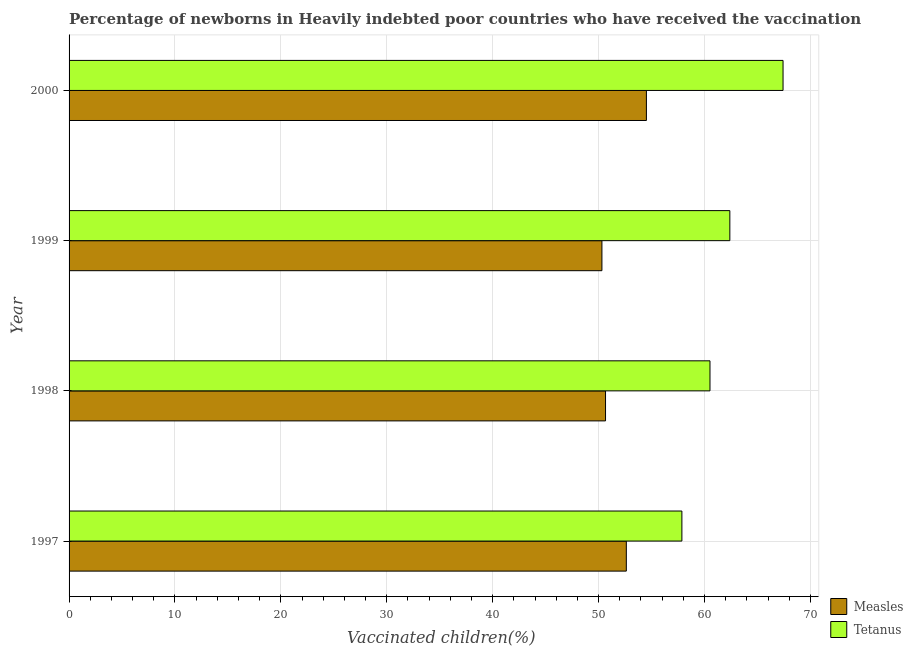How many different coloured bars are there?
Provide a short and direct response. 2. How many groups of bars are there?
Make the answer very short. 4. Are the number of bars per tick equal to the number of legend labels?
Your answer should be compact. Yes. How many bars are there on the 4th tick from the bottom?
Keep it short and to the point. 2. What is the label of the 3rd group of bars from the top?
Your answer should be compact. 1998. In how many cases, is the number of bars for a given year not equal to the number of legend labels?
Your answer should be compact. 0. What is the percentage of newborns who received vaccination for measles in 1997?
Provide a short and direct response. 52.62. Across all years, what is the maximum percentage of newborns who received vaccination for measles?
Keep it short and to the point. 54.51. Across all years, what is the minimum percentage of newborns who received vaccination for tetanus?
Your answer should be compact. 57.86. In which year was the percentage of newborns who received vaccination for tetanus minimum?
Your response must be concise. 1997. What is the total percentage of newborns who received vaccination for tetanus in the graph?
Keep it short and to the point. 248.18. What is the difference between the percentage of newborns who received vaccination for tetanus in 1998 and that in 2000?
Provide a succinct answer. -6.9. What is the difference between the percentage of newborns who received vaccination for tetanus in 1997 and the percentage of newborns who received vaccination for measles in 1999?
Keep it short and to the point. 7.55. What is the average percentage of newborns who received vaccination for measles per year?
Keep it short and to the point. 52.02. In the year 1998, what is the difference between the percentage of newborns who received vaccination for tetanus and percentage of newborns who received vaccination for measles?
Your answer should be very brief. 9.86. What is the ratio of the percentage of newborns who received vaccination for tetanus in 1999 to that in 2000?
Make the answer very short. 0.93. Is the percentage of newborns who received vaccination for measles in 1999 less than that in 2000?
Provide a succinct answer. Yes. What is the difference between the highest and the second highest percentage of newborns who received vaccination for tetanus?
Offer a terse response. 5.02. What is the difference between the highest and the lowest percentage of newborns who received vaccination for tetanus?
Ensure brevity in your answer.  9.55. In how many years, is the percentage of newborns who received vaccination for measles greater than the average percentage of newborns who received vaccination for measles taken over all years?
Make the answer very short. 2. Is the sum of the percentage of newborns who received vaccination for measles in 1998 and 2000 greater than the maximum percentage of newborns who received vaccination for tetanus across all years?
Your response must be concise. Yes. What does the 1st bar from the top in 1999 represents?
Your answer should be compact. Tetanus. What does the 2nd bar from the bottom in 2000 represents?
Offer a very short reply. Tetanus. How many years are there in the graph?
Ensure brevity in your answer.  4. Does the graph contain grids?
Provide a succinct answer. Yes. How many legend labels are there?
Keep it short and to the point. 2. What is the title of the graph?
Your answer should be very brief. Percentage of newborns in Heavily indebted poor countries who have received the vaccination. Does "Arms imports" appear as one of the legend labels in the graph?
Provide a succinct answer. No. What is the label or title of the X-axis?
Provide a short and direct response. Vaccinated children(%)
. What is the label or title of the Y-axis?
Offer a terse response. Year. What is the Vaccinated children(%)
 in Measles in 1997?
Make the answer very short. 52.62. What is the Vaccinated children(%)
 in Tetanus in 1997?
Keep it short and to the point. 57.86. What is the Vaccinated children(%)
 in Measles in 1998?
Offer a terse response. 50.65. What is the Vaccinated children(%)
 in Tetanus in 1998?
Provide a short and direct response. 60.52. What is the Vaccinated children(%)
 in Measles in 1999?
Provide a short and direct response. 50.31. What is the Vaccinated children(%)
 in Tetanus in 1999?
Your answer should be very brief. 62.39. What is the Vaccinated children(%)
 in Measles in 2000?
Make the answer very short. 54.51. What is the Vaccinated children(%)
 of Tetanus in 2000?
Your answer should be compact. 67.41. Across all years, what is the maximum Vaccinated children(%)
 of Measles?
Offer a terse response. 54.51. Across all years, what is the maximum Vaccinated children(%)
 of Tetanus?
Keep it short and to the point. 67.41. Across all years, what is the minimum Vaccinated children(%)
 in Measles?
Make the answer very short. 50.31. Across all years, what is the minimum Vaccinated children(%)
 in Tetanus?
Ensure brevity in your answer.  57.86. What is the total Vaccinated children(%)
 in Measles in the graph?
Your answer should be very brief. 208.09. What is the total Vaccinated children(%)
 in Tetanus in the graph?
Keep it short and to the point. 248.18. What is the difference between the Vaccinated children(%)
 in Measles in 1997 and that in 1998?
Provide a short and direct response. 1.96. What is the difference between the Vaccinated children(%)
 of Tetanus in 1997 and that in 1998?
Your answer should be very brief. -2.65. What is the difference between the Vaccinated children(%)
 in Measles in 1997 and that in 1999?
Give a very brief answer. 2.3. What is the difference between the Vaccinated children(%)
 of Tetanus in 1997 and that in 1999?
Offer a very short reply. -4.53. What is the difference between the Vaccinated children(%)
 in Measles in 1997 and that in 2000?
Offer a terse response. -1.9. What is the difference between the Vaccinated children(%)
 of Tetanus in 1997 and that in 2000?
Your answer should be compact. -9.55. What is the difference between the Vaccinated children(%)
 of Measles in 1998 and that in 1999?
Ensure brevity in your answer.  0.34. What is the difference between the Vaccinated children(%)
 in Tetanus in 1998 and that in 1999?
Your answer should be compact. -1.87. What is the difference between the Vaccinated children(%)
 of Measles in 1998 and that in 2000?
Offer a terse response. -3.86. What is the difference between the Vaccinated children(%)
 of Tetanus in 1998 and that in 2000?
Your answer should be compact. -6.9. What is the difference between the Vaccinated children(%)
 in Measles in 1999 and that in 2000?
Offer a very short reply. -4.2. What is the difference between the Vaccinated children(%)
 in Tetanus in 1999 and that in 2000?
Your response must be concise. -5.02. What is the difference between the Vaccinated children(%)
 in Measles in 1997 and the Vaccinated children(%)
 in Tetanus in 1998?
Provide a succinct answer. -7.9. What is the difference between the Vaccinated children(%)
 of Measles in 1997 and the Vaccinated children(%)
 of Tetanus in 1999?
Offer a very short reply. -9.77. What is the difference between the Vaccinated children(%)
 of Measles in 1997 and the Vaccinated children(%)
 of Tetanus in 2000?
Offer a terse response. -14.8. What is the difference between the Vaccinated children(%)
 of Measles in 1998 and the Vaccinated children(%)
 of Tetanus in 1999?
Offer a terse response. -11.74. What is the difference between the Vaccinated children(%)
 of Measles in 1998 and the Vaccinated children(%)
 of Tetanus in 2000?
Your answer should be very brief. -16.76. What is the difference between the Vaccinated children(%)
 of Measles in 1999 and the Vaccinated children(%)
 of Tetanus in 2000?
Offer a very short reply. -17.1. What is the average Vaccinated children(%)
 in Measles per year?
Give a very brief answer. 52.02. What is the average Vaccinated children(%)
 of Tetanus per year?
Give a very brief answer. 62.05. In the year 1997, what is the difference between the Vaccinated children(%)
 of Measles and Vaccinated children(%)
 of Tetanus?
Offer a terse response. -5.25. In the year 1998, what is the difference between the Vaccinated children(%)
 in Measles and Vaccinated children(%)
 in Tetanus?
Offer a terse response. -9.86. In the year 1999, what is the difference between the Vaccinated children(%)
 of Measles and Vaccinated children(%)
 of Tetanus?
Your response must be concise. -12.08. In the year 2000, what is the difference between the Vaccinated children(%)
 in Measles and Vaccinated children(%)
 in Tetanus?
Make the answer very short. -12.9. What is the ratio of the Vaccinated children(%)
 of Measles in 1997 to that in 1998?
Your response must be concise. 1.04. What is the ratio of the Vaccinated children(%)
 in Tetanus in 1997 to that in 1998?
Offer a very short reply. 0.96. What is the ratio of the Vaccinated children(%)
 of Measles in 1997 to that in 1999?
Offer a very short reply. 1.05. What is the ratio of the Vaccinated children(%)
 of Tetanus in 1997 to that in 1999?
Your answer should be compact. 0.93. What is the ratio of the Vaccinated children(%)
 in Measles in 1997 to that in 2000?
Your answer should be very brief. 0.97. What is the ratio of the Vaccinated children(%)
 in Tetanus in 1997 to that in 2000?
Provide a succinct answer. 0.86. What is the ratio of the Vaccinated children(%)
 of Measles in 1998 to that in 1999?
Ensure brevity in your answer.  1.01. What is the ratio of the Vaccinated children(%)
 of Measles in 1998 to that in 2000?
Offer a very short reply. 0.93. What is the ratio of the Vaccinated children(%)
 of Tetanus in 1998 to that in 2000?
Give a very brief answer. 0.9. What is the ratio of the Vaccinated children(%)
 of Measles in 1999 to that in 2000?
Your answer should be compact. 0.92. What is the ratio of the Vaccinated children(%)
 of Tetanus in 1999 to that in 2000?
Provide a short and direct response. 0.93. What is the difference between the highest and the second highest Vaccinated children(%)
 in Measles?
Keep it short and to the point. 1.9. What is the difference between the highest and the second highest Vaccinated children(%)
 of Tetanus?
Provide a succinct answer. 5.02. What is the difference between the highest and the lowest Vaccinated children(%)
 of Measles?
Keep it short and to the point. 4.2. What is the difference between the highest and the lowest Vaccinated children(%)
 of Tetanus?
Give a very brief answer. 9.55. 